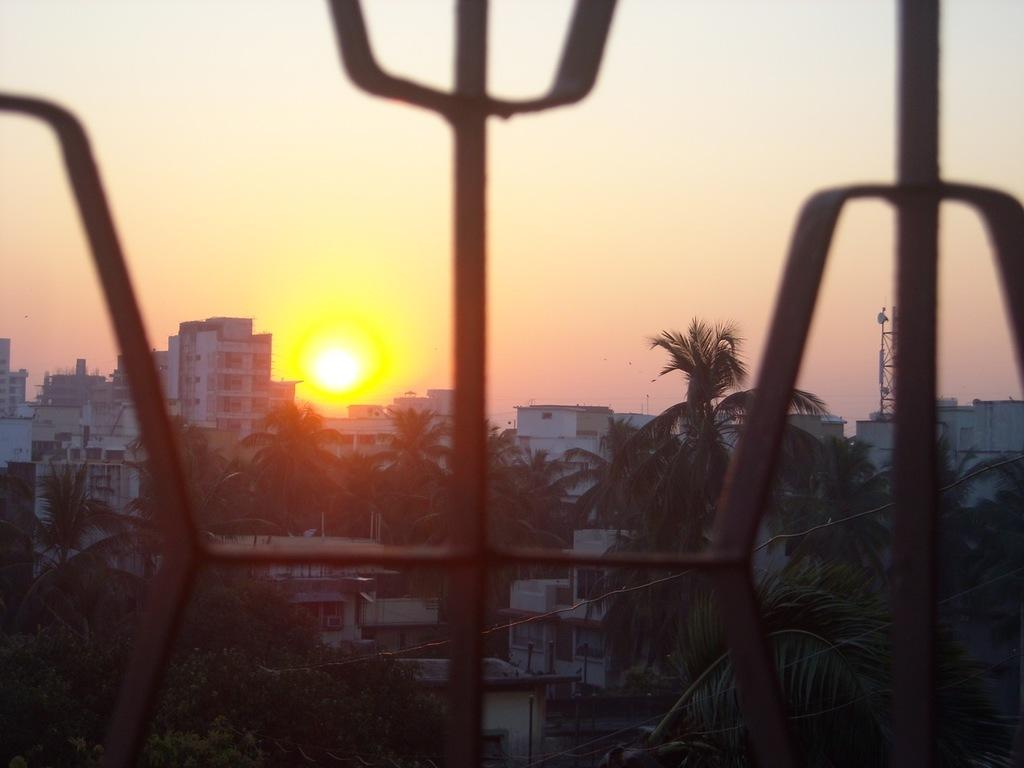What type of structures can be seen in the image? There are buildings in the image. What other natural elements are present in the image? There are trees in the image. What specific feature stands out among the buildings? There is a tower in the image. What can be seen in the sky in the background of the image? The sun and sky are visible in the background of the image. How many cans of soda are placed on the rail in the image? There is no rail or soda present in the image. What type of mass is visible in the image? There is no mass visible in the image; the main subjects are buildings, trees, and a tower. 